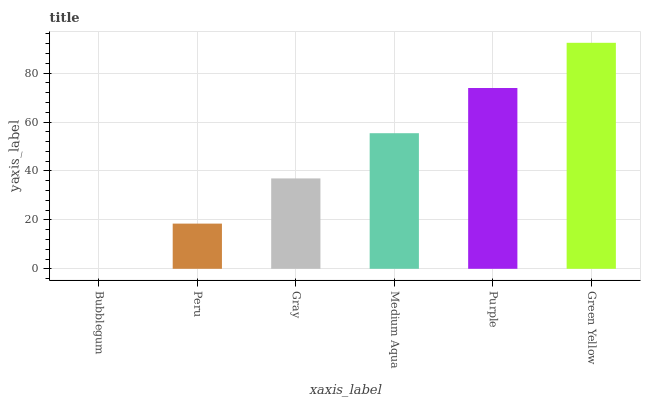Is Bubblegum the minimum?
Answer yes or no. Yes. Is Green Yellow the maximum?
Answer yes or no. Yes. Is Peru the minimum?
Answer yes or no. No. Is Peru the maximum?
Answer yes or no. No. Is Peru greater than Bubblegum?
Answer yes or no. Yes. Is Bubblegum less than Peru?
Answer yes or no. Yes. Is Bubblegum greater than Peru?
Answer yes or no. No. Is Peru less than Bubblegum?
Answer yes or no. No. Is Medium Aqua the high median?
Answer yes or no. Yes. Is Gray the low median?
Answer yes or no. Yes. Is Peru the high median?
Answer yes or no. No. Is Bubblegum the low median?
Answer yes or no. No. 